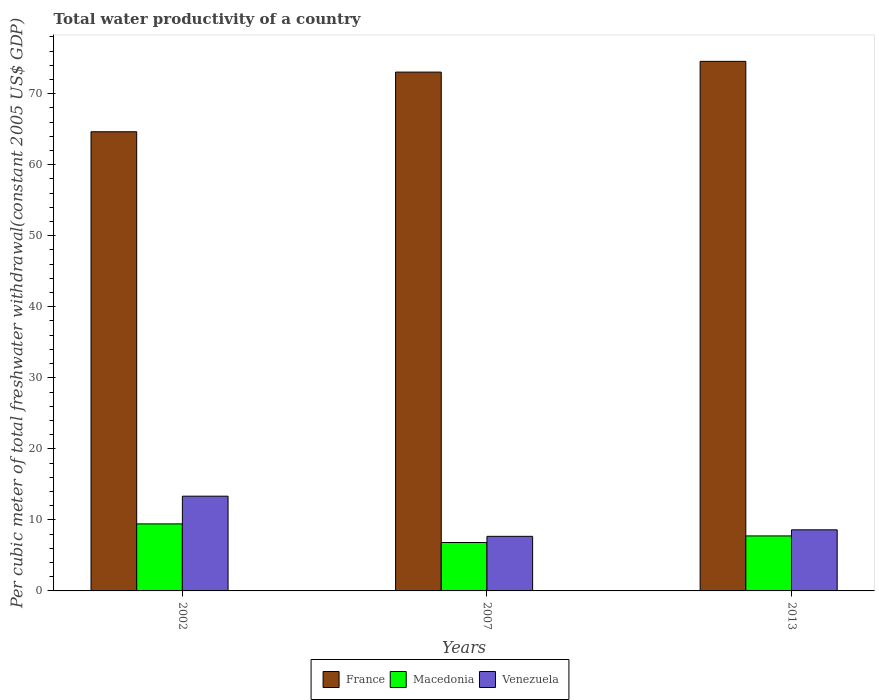Are the number of bars per tick equal to the number of legend labels?
Your answer should be very brief. Yes. How many bars are there on the 1st tick from the right?
Your response must be concise. 3. What is the label of the 3rd group of bars from the left?
Keep it short and to the point. 2013. In how many cases, is the number of bars for a given year not equal to the number of legend labels?
Provide a succinct answer. 0. What is the total water productivity in Macedonia in 2002?
Your answer should be compact. 9.43. Across all years, what is the maximum total water productivity in Macedonia?
Keep it short and to the point. 9.43. Across all years, what is the minimum total water productivity in Venezuela?
Offer a very short reply. 7.68. In which year was the total water productivity in France maximum?
Give a very brief answer. 2013. What is the total total water productivity in France in the graph?
Provide a short and direct response. 212.21. What is the difference between the total water productivity in Macedonia in 2007 and that in 2013?
Offer a very short reply. -0.93. What is the difference between the total water productivity in Macedonia in 2002 and the total water productivity in Venezuela in 2013?
Offer a terse response. 0.83. What is the average total water productivity in France per year?
Provide a succinct answer. 70.74. In the year 2013, what is the difference between the total water productivity in Macedonia and total water productivity in Venezuela?
Keep it short and to the point. -0.86. What is the ratio of the total water productivity in Venezuela in 2002 to that in 2013?
Give a very brief answer. 1.55. What is the difference between the highest and the second highest total water productivity in Macedonia?
Your answer should be very brief. 1.69. What is the difference between the highest and the lowest total water productivity in Macedonia?
Ensure brevity in your answer.  2.62. What does the 1st bar from the left in 2013 represents?
Keep it short and to the point. France. What does the 1st bar from the right in 2007 represents?
Your answer should be very brief. Venezuela. Is it the case that in every year, the sum of the total water productivity in France and total water productivity in Macedonia is greater than the total water productivity in Venezuela?
Ensure brevity in your answer.  Yes. How many bars are there?
Make the answer very short. 9. What is the difference between two consecutive major ticks on the Y-axis?
Your answer should be compact. 10. Does the graph contain any zero values?
Make the answer very short. No. What is the title of the graph?
Keep it short and to the point. Total water productivity of a country. Does "Arab World" appear as one of the legend labels in the graph?
Offer a terse response. No. What is the label or title of the X-axis?
Ensure brevity in your answer.  Years. What is the label or title of the Y-axis?
Your answer should be compact. Per cubic meter of total freshwater withdrawal(constant 2005 US$ GDP). What is the Per cubic meter of total freshwater withdrawal(constant 2005 US$ GDP) of France in 2002?
Offer a terse response. 64.63. What is the Per cubic meter of total freshwater withdrawal(constant 2005 US$ GDP) of Macedonia in 2002?
Provide a succinct answer. 9.43. What is the Per cubic meter of total freshwater withdrawal(constant 2005 US$ GDP) in Venezuela in 2002?
Offer a very short reply. 13.34. What is the Per cubic meter of total freshwater withdrawal(constant 2005 US$ GDP) in France in 2007?
Give a very brief answer. 73.03. What is the Per cubic meter of total freshwater withdrawal(constant 2005 US$ GDP) of Macedonia in 2007?
Your answer should be compact. 6.82. What is the Per cubic meter of total freshwater withdrawal(constant 2005 US$ GDP) of Venezuela in 2007?
Keep it short and to the point. 7.68. What is the Per cubic meter of total freshwater withdrawal(constant 2005 US$ GDP) of France in 2013?
Provide a short and direct response. 74.55. What is the Per cubic meter of total freshwater withdrawal(constant 2005 US$ GDP) of Macedonia in 2013?
Your answer should be very brief. 7.74. What is the Per cubic meter of total freshwater withdrawal(constant 2005 US$ GDP) of Venezuela in 2013?
Offer a very short reply. 8.6. Across all years, what is the maximum Per cubic meter of total freshwater withdrawal(constant 2005 US$ GDP) in France?
Make the answer very short. 74.55. Across all years, what is the maximum Per cubic meter of total freshwater withdrawal(constant 2005 US$ GDP) in Macedonia?
Provide a short and direct response. 9.43. Across all years, what is the maximum Per cubic meter of total freshwater withdrawal(constant 2005 US$ GDP) in Venezuela?
Make the answer very short. 13.34. Across all years, what is the minimum Per cubic meter of total freshwater withdrawal(constant 2005 US$ GDP) of France?
Your response must be concise. 64.63. Across all years, what is the minimum Per cubic meter of total freshwater withdrawal(constant 2005 US$ GDP) of Macedonia?
Your response must be concise. 6.82. Across all years, what is the minimum Per cubic meter of total freshwater withdrawal(constant 2005 US$ GDP) in Venezuela?
Your answer should be compact. 7.68. What is the total Per cubic meter of total freshwater withdrawal(constant 2005 US$ GDP) in France in the graph?
Provide a succinct answer. 212.21. What is the total Per cubic meter of total freshwater withdrawal(constant 2005 US$ GDP) in Macedonia in the graph?
Offer a very short reply. 23.99. What is the total Per cubic meter of total freshwater withdrawal(constant 2005 US$ GDP) in Venezuela in the graph?
Offer a very short reply. 29.62. What is the difference between the Per cubic meter of total freshwater withdrawal(constant 2005 US$ GDP) of France in 2002 and that in 2007?
Provide a succinct answer. -8.4. What is the difference between the Per cubic meter of total freshwater withdrawal(constant 2005 US$ GDP) in Macedonia in 2002 and that in 2007?
Your answer should be compact. 2.62. What is the difference between the Per cubic meter of total freshwater withdrawal(constant 2005 US$ GDP) in Venezuela in 2002 and that in 2007?
Your response must be concise. 5.65. What is the difference between the Per cubic meter of total freshwater withdrawal(constant 2005 US$ GDP) in France in 2002 and that in 2013?
Ensure brevity in your answer.  -9.91. What is the difference between the Per cubic meter of total freshwater withdrawal(constant 2005 US$ GDP) of Macedonia in 2002 and that in 2013?
Your answer should be compact. 1.69. What is the difference between the Per cubic meter of total freshwater withdrawal(constant 2005 US$ GDP) in Venezuela in 2002 and that in 2013?
Make the answer very short. 4.74. What is the difference between the Per cubic meter of total freshwater withdrawal(constant 2005 US$ GDP) of France in 2007 and that in 2013?
Provide a short and direct response. -1.51. What is the difference between the Per cubic meter of total freshwater withdrawal(constant 2005 US$ GDP) of Macedonia in 2007 and that in 2013?
Ensure brevity in your answer.  -0.93. What is the difference between the Per cubic meter of total freshwater withdrawal(constant 2005 US$ GDP) of Venezuela in 2007 and that in 2013?
Make the answer very short. -0.92. What is the difference between the Per cubic meter of total freshwater withdrawal(constant 2005 US$ GDP) in France in 2002 and the Per cubic meter of total freshwater withdrawal(constant 2005 US$ GDP) in Macedonia in 2007?
Give a very brief answer. 57.82. What is the difference between the Per cubic meter of total freshwater withdrawal(constant 2005 US$ GDP) in France in 2002 and the Per cubic meter of total freshwater withdrawal(constant 2005 US$ GDP) in Venezuela in 2007?
Offer a terse response. 56.95. What is the difference between the Per cubic meter of total freshwater withdrawal(constant 2005 US$ GDP) of Macedonia in 2002 and the Per cubic meter of total freshwater withdrawal(constant 2005 US$ GDP) of Venezuela in 2007?
Ensure brevity in your answer.  1.75. What is the difference between the Per cubic meter of total freshwater withdrawal(constant 2005 US$ GDP) of France in 2002 and the Per cubic meter of total freshwater withdrawal(constant 2005 US$ GDP) of Macedonia in 2013?
Offer a very short reply. 56.89. What is the difference between the Per cubic meter of total freshwater withdrawal(constant 2005 US$ GDP) of France in 2002 and the Per cubic meter of total freshwater withdrawal(constant 2005 US$ GDP) of Venezuela in 2013?
Make the answer very short. 56.03. What is the difference between the Per cubic meter of total freshwater withdrawal(constant 2005 US$ GDP) in Macedonia in 2002 and the Per cubic meter of total freshwater withdrawal(constant 2005 US$ GDP) in Venezuela in 2013?
Ensure brevity in your answer.  0.83. What is the difference between the Per cubic meter of total freshwater withdrawal(constant 2005 US$ GDP) of France in 2007 and the Per cubic meter of total freshwater withdrawal(constant 2005 US$ GDP) of Macedonia in 2013?
Keep it short and to the point. 65.29. What is the difference between the Per cubic meter of total freshwater withdrawal(constant 2005 US$ GDP) of France in 2007 and the Per cubic meter of total freshwater withdrawal(constant 2005 US$ GDP) of Venezuela in 2013?
Make the answer very short. 64.43. What is the difference between the Per cubic meter of total freshwater withdrawal(constant 2005 US$ GDP) in Macedonia in 2007 and the Per cubic meter of total freshwater withdrawal(constant 2005 US$ GDP) in Venezuela in 2013?
Offer a terse response. -1.79. What is the average Per cubic meter of total freshwater withdrawal(constant 2005 US$ GDP) of France per year?
Give a very brief answer. 70.74. What is the average Per cubic meter of total freshwater withdrawal(constant 2005 US$ GDP) of Macedonia per year?
Your answer should be compact. 8. What is the average Per cubic meter of total freshwater withdrawal(constant 2005 US$ GDP) in Venezuela per year?
Your response must be concise. 9.87. In the year 2002, what is the difference between the Per cubic meter of total freshwater withdrawal(constant 2005 US$ GDP) of France and Per cubic meter of total freshwater withdrawal(constant 2005 US$ GDP) of Macedonia?
Provide a short and direct response. 55.2. In the year 2002, what is the difference between the Per cubic meter of total freshwater withdrawal(constant 2005 US$ GDP) in France and Per cubic meter of total freshwater withdrawal(constant 2005 US$ GDP) in Venezuela?
Offer a terse response. 51.3. In the year 2002, what is the difference between the Per cubic meter of total freshwater withdrawal(constant 2005 US$ GDP) of Macedonia and Per cubic meter of total freshwater withdrawal(constant 2005 US$ GDP) of Venezuela?
Make the answer very short. -3.9. In the year 2007, what is the difference between the Per cubic meter of total freshwater withdrawal(constant 2005 US$ GDP) of France and Per cubic meter of total freshwater withdrawal(constant 2005 US$ GDP) of Macedonia?
Your answer should be compact. 66.22. In the year 2007, what is the difference between the Per cubic meter of total freshwater withdrawal(constant 2005 US$ GDP) of France and Per cubic meter of total freshwater withdrawal(constant 2005 US$ GDP) of Venezuela?
Make the answer very short. 65.35. In the year 2007, what is the difference between the Per cubic meter of total freshwater withdrawal(constant 2005 US$ GDP) in Macedonia and Per cubic meter of total freshwater withdrawal(constant 2005 US$ GDP) in Venezuela?
Offer a very short reply. -0.87. In the year 2013, what is the difference between the Per cubic meter of total freshwater withdrawal(constant 2005 US$ GDP) in France and Per cubic meter of total freshwater withdrawal(constant 2005 US$ GDP) in Macedonia?
Provide a succinct answer. 66.8. In the year 2013, what is the difference between the Per cubic meter of total freshwater withdrawal(constant 2005 US$ GDP) of France and Per cubic meter of total freshwater withdrawal(constant 2005 US$ GDP) of Venezuela?
Your answer should be compact. 65.94. In the year 2013, what is the difference between the Per cubic meter of total freshwater withdrawal(constant 2005 US$ GDP) in Macedonia and Per cubic meter of total freshwater withdrawal(constant 2005 US$ GDP) in Venezuela?
Provide a succinct answer. -0.86. What is the ratio of the Per cubic meter of total freshwater withdrawal(constant 2005 US$ GDP) in France in 2002 to that in 2007?
Give a very brief answer. 0.89. What is the ratio of the Per cubic meter of total freshwater withdrawal(constant 2005 US$ GDP) in Macedonia in 2002 to that in 2007?
Your answer should be compact. 1.38. What is the ratio of the Per cubic meter of total freshwater withdrawal(constant 2005 US$ GDP) of Venezuela in 2002 to that in 2007?
Offer a terse response. 1.74. What is the ratio of the Per cubic meter of total freshwater withdrawal(constant 2005 US$ GDP) in France in 2002 to that in 2013?
Your answer should be compact. 0.87. What is the ratio of the Per cubic meter of total freshwater withdrawal(constant 2005 US$ GDP) of Macedonia in 2002 to that in 2013?
Provide a succinct answer. 1.22. What is the ratio of the Per cubic meter of total freshwater withdrawal(constant 2005 US$ GDP) of Venezuela in 2002 to that in 2013?
Keep it short and to the point. 1.55. What is the ratio of the Per cubic meter of total freshwater withdrawal(constant 2005 US$ GDP) of France in 2007 to that in 2013?
Provide a succinct answer. 0.98. What is the ratio of the Per cubic meter of total freshwater withdrawal(constant 2005 US$ GDP) of Macedonia in 2007 to that in 2013?
Ensure brevity in your answer.  0.88. What is the ratio of the Per cubic meter of total freshwater withdrawal(constant 2005 US$ GDP) in Venezuela in 2007 to that in 2013?
Give a very brief answer. 0.89. What is the difference between the highest and the second highest Per cubic meter of total freshwater withdrawal(constant 2005 US$ GDP) in France?
Your answer should be very brief. 1.51. What is the difference between the highest and the second highest Per cubic meter of total freshwater withdrawal(constant 2005 US$ GDP) in Macedonia?
Provide a succinct answer. 1.69. What is the difference between the highest and the second highest Per cubic meter of total freshwater withdrawal(constant 2005 US$ GDP) of Venezuela?
Offer a terse response. 4.74. What is the difference between the highest and the lowest Per cubic meter of total freshwater withdrawal(constant 2005 US$ GDP) of France?
Your answer should be compact. 9.91. What is the difference between the highest and the lowest Per cubic meter of total freshwater withdrawal(constant 2005 US$ GDP) in Macedonia?
Offer a very short reply. 2.62. What is the difference between the highest and the lowest Per cubic meter of total freshwater withdrawal(constant 2005 US$ GDP) of Venezuela?
Offer a very short reply. 5.65. 